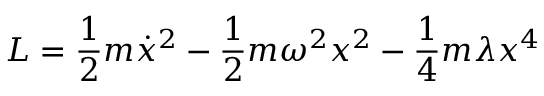<formula> <loc_0><loc_0><loc_500><loc_500>L = \frac { 1 } { 2 } m \dot { x } ^ { 2 } - \frac { 1 } { 2 } m { \omega } ^ { 2 } x ^ { 2 } - \frac { 1 } { 4 } m \lambda x ^ { 4 }</formula> 